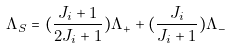<formula> <loc_0><loc_0><loc_500><loc_500>\Lambda _ { S } = ( \frac { J _ { i } + 1 } { 2 J _ { i } + 1 } ) \Lambda _ { + } + ( \frac { J _ { i } } { J _ { i } + 1 } ) \Lambda _ { - }</formula> 